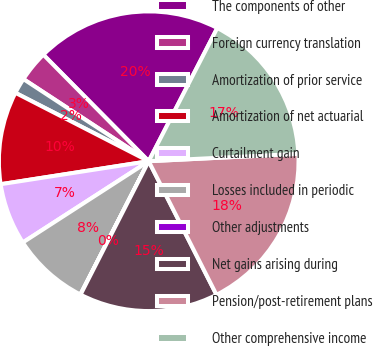Convert chart. <chart><loc_0><loc_0><loc_500><loc_500><pie_chart><fcel>The components of other<fcel>Foreign currency translation<fcel>Amortization of prior service<fcel>Amortization of net actuarial<fcel>Curtailment gain<fcel>Losses included in periodic<fcel>Other adjustments<fcel>Net gains arising during<fcel>Pension/post-retirement plans<fcel>Other comprehensive income<nl><fcel>19.98%<fcel>3.35%<fcel>1.69%<fcel>10.0%<fcel>6.67%<fcel>8.34%<fcel>0.02%<fcel>14.99%<fcel>18.31%<fcel>16.65%<nl></chart> 